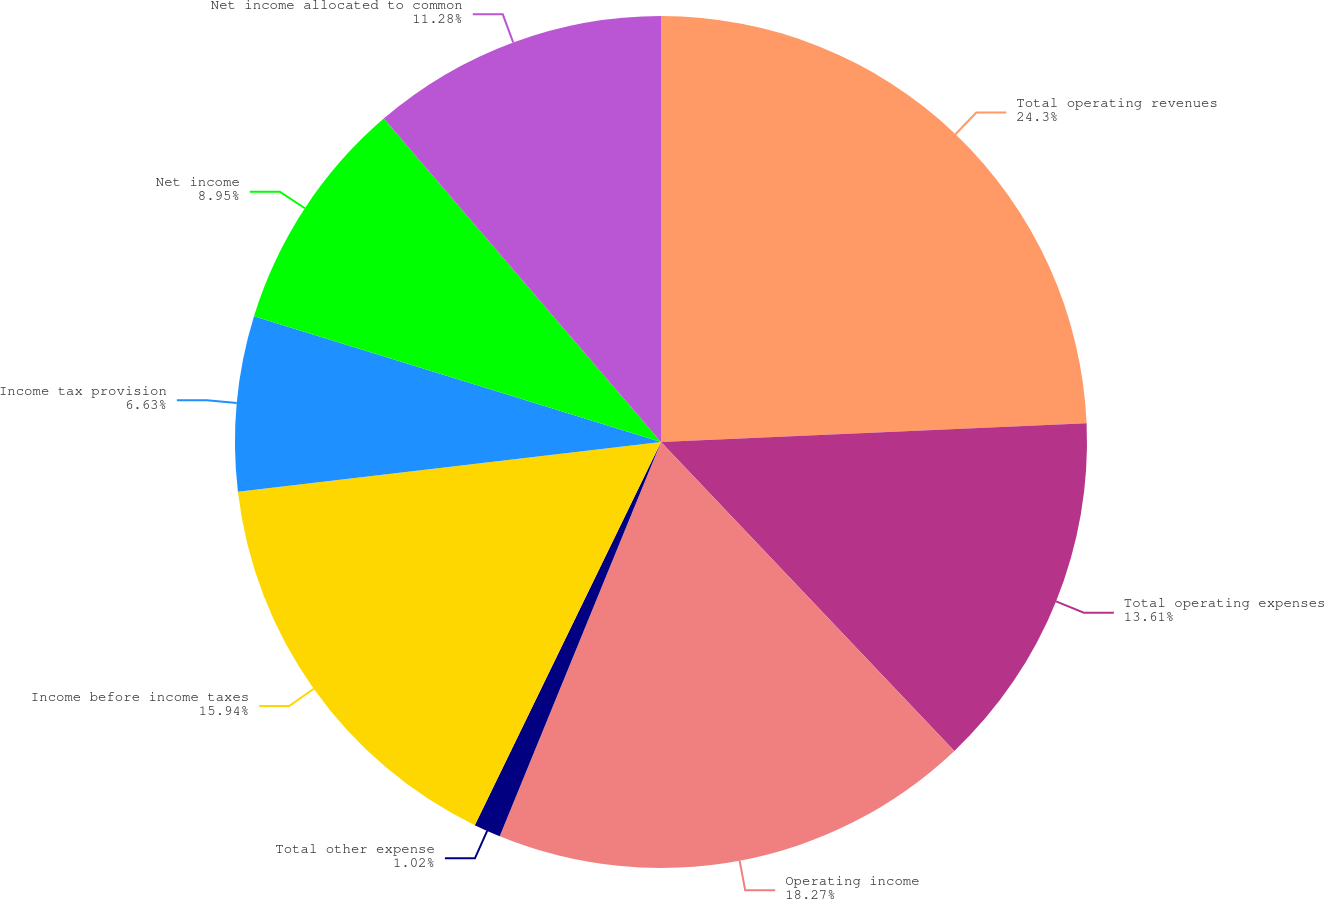Convert chart. <chart><loc_0><loc_0><loc_500><loc_500><pie_chart><fcel>Total operating revenues<fcel>Total operating expenses<fcel>Operating income<fcel>Total other expense<fcel>Income before income taxes<fcel>Income tax provision<fcel>Net income<fcel>Net income allocated to common<nl><fcel>24.3%<fcel>13.61%<fcel>18.27%<fcel>1.02%<fcel>15.94%<fcel>6.63%<fcel>8.95%<fcel>11.28%<nl></chart> 